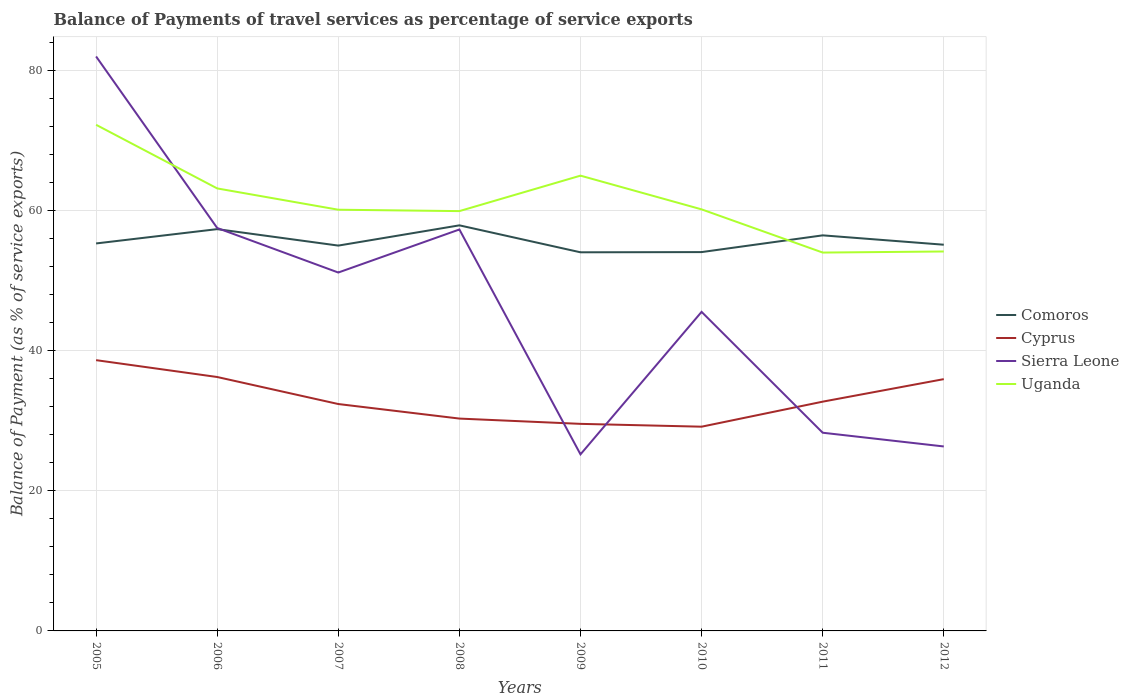How many different coloured lines are there?
Keep it short and to the point. 4. Across all years, what is the maximum balance of payments of travel services in Comoros?
Provide a short and direct response. 54.01. What is the total balance of payments of travel services in Uganda in the graph?
Offer a terse response. 2.99. What is the difference between the highest and the second highest balance of payments of travel services in Comoros?
Your answer should be very brief. 3.85. Is the balance of payments of travel services in Comoros strictly greater than the balance of payments of travel services in Sierra Leone over the years?
Give a very brief answer. No. How many years are there in the graph?
Make the answer very short. 8. How are the legend labels stacked?
Ensure brevity in your answer.  Vertical. What is the title of the graph?
Make the answer very short. Balance of Payments of travel services as percentage of service exports. Does "Senegal" appear as one of the legend labels in the graph?
Your answer should be very brief. No. What is the label or title of the Y-axis?
Provide a succinct answer. Balance of Payment (as % of service exports). What is the Balance of Payment (as % of service exports) of Comoros in 2005?
Offer a terse response. 55.27. What is the Balance of Payment (as % of service exports) of Cyprus in 2005?
Give a very brief answer. 38.62. What is the Balance of Payment (as % of service exports) in Sierra Leone in 2005?
Ensure brevity in your answer.  81.94. What is the Balance of Payment (as % of service exports) in Uganda in 2005?
Keep it short and to the point. 72.2. What is the Balance of Payment (as % of service exports) in Comoros in 2006?
Make the answer very short. 57.31. What is the Balance of Payment (as % of service exports) of Cyprus in 2006?
Keep it short and to the point. 36.22. What is the Balance of Payment (as % of service exports) of Sierra Leone in 2006?
Provide a succinct answer. 57.47. What is the Balance of Payment (as % of service exports) in Uganda in 2006?
Make the answer very short. 63.12. What is the Balance of Payment (as % of service exports) of Comoros in 2007?
Give a very brief answer. 54.96. What is the Balance of Payment (as % of service exports) in Cyprus in 2007?
Make the answer very short. 32.36. What is the Balance of Payment (as % of service exports) of Sierra Leone in 2007?
Ensure brevity in your answer.  51.12. What is the Balance of Payment (as % of service exports) in Uganda in 2007?
Your response must be concise. 60.08. What is the Balance of Payment (as % of service exports) in Comoros in 2008?
Keep it short and to the point. 57.85. What is the Balance of Payment (as % of service exports) of Cyprus in 2008?
Offer a terse response. 30.29. What is the Balance of Payment (as % of service exports) in Sierra Leone in 2008?
Your answer should be very brief. 57.26. What is the Balance of Payment (as % of service exports) of Uganda in 2008?
Your answer should be compact. 59.88. What is the Balance of Payment (as % of service exports) in Comoros in 2009?
Keep it short and to the point. 54.01. What is the Balance of Payment (as % of service exports) in Cyprus in 2009?
Make the answer very short. 29.53. What is the Balance of Payment (as % of service exports) in Sierra Leone in 2009?
Your response must be concise. 25.19. What is the Balance of Payment (as % of service exports) of Uganda in 2009?
Provide a succinct answer. 64.94. What is the Balance of Payment (as % of service exports) of Comoros in 2010?
Ensure brevity in your answer.  54.04. What is the Balance of Payment (as % of service exports) of Cyprus in 2010?
Your answer should be compact. 29.13. What is the Balance of Payment (as % of service exports) in Sierra Leone in 2010?
Offer a very short reply. 45.51. What is the Balance of Payment (as % of service exports) in Uganda in 2010?
Offer a very short reply. 60.13. What is the Balance of Payment (as % of service exports) in Comoros in 2011?
Your answer should be compact. 56.42. What is the Balance of Payment (as % of service exports) of Cyprus in 2011?
Give a very brief answer. 32.7. What is the Balance of Payment (as % of service exports) in Sierra Leone in 2011?
Ensure brevity in your answer.  28.27. What is the Balance of Payment (as % of service exports) in Uganda in 2011?
Your answer should be compact. 53.97. What is the Balance of Payment (as % of service exports) in Comoros in 2012?
Your response must be concise. 55.09. What is the Balance of Payment (as % of service exports) in Cyprus in 2012?
Your response must be concise. 35.91. What is the Balance of Payment (as % of service exports) in Sierra Leone in 2012?
Offer a terse response. 26.31. What is the Balance of Payment (as % of service exports) in Uganda in 2012?
Your answer should be compact. 54.12. Across all years, what is the maximum Balance of Payment (as % of service exports) of Comoros?
Provide a short and direct response. 57.85. Across all years, what is the maximum Balance of Payment (as % of service exports) of Cyprus?
Ensure brevity in your answer.  38.62. Across all years, what is the maximum Balance of Payment (as % of service exports) in Sierra Leone?
Ensure brevity in your answer.  81.94. Across all years, what is the maximum Balance of Payment (as % of service exports) of Uganda?
Offer a terse response. 72.2. Across all years, what is the minimum Balance of Payment (as % of service exports) of Comoros?
Make the answer very short. 54.01. Across all years, what is the minimum Balance of Payment (as % of service exports) in Cyprus?
Provide a short and direct response. 29.13. Across all years, what is the minimum Balance of Payment (as % of service exports) of Sierra Leone?
Ensure brevity in your answer.  25.19. Across all years, what is the minimum Balance of Payment (as % of service exports) in Uganda?
Provide a succinct answer. 53.97. What is the total Balance of Payment (as % of service exports) in Comoros in the graph?
Ensure brevity in your answer.  444.95. What is the total Balance of Payment (as % of service exports) of Cyprus in the graph?
Offer a very short reply. 264.78. What is the total Balance of Payment (as % of service exports) of Sierra Leone in the graph?
Offer a very short reply. 373.07. What is the total Balance of Payment (as % of service exports) in Uganda in the graph?
Offer a terse response. 488.44. What is the difference between the Balance of Payment (as % of service exports) in Comoros in 2005 and that in 2006?
Provide a succinct answer. -2.04. What is the difference between the Balance of Payment (as % of service exports) of Cyprus in 2005 and that in 2006?
Make the answer very short. 2.4. What is the difference between the Balance of Payment (as % of service exports) in Sierra Leone in 2005 and that in 2006?
Your answer should be compact. 24.47. What is the difference between the Balance of Payment (as % of service exports) in Uganda in 2005 and that in 2006?
Ensure brevity in your answer.  9.08. What is the difference between the Balance of Payment (as % of service exports) of Comoros in 2005 and that in 2007?
Give a very brief answer. 0.31. What is the difference between the Balance of Payment (as % of service exports) of Cyprus in 2005 and that in 2007?
Offer a very short reply. 6.26. What is the difference between the Balance of Payment (as % of service exports) in Sierra Leone in 2005 and that in 2007?
Ensure brevity in your answer.  30.82. What is the difference between the Balance of Payment (as % of service exports) in Uganda in 2005 and that in 2007?
Make the answer very short. 12.11. What is the difference between the Balance of Payment (as % of service exports) of Comoros in 2005 and that in 2008?
Your answer should be compact. -2.58. What is the difference between the Balance of Payment (as % of service exports) of Cyprus in 2005 and that in 2008?
Provide a short and direct response. 8.33. What is the difference between the Balance of Payment (as % of service exports) in Sierra Leone in 2005 and that in 2008?
Provide a succinct answer. 24.68. What is the difference between the Balance of Payment (as % of service exports) of Uganda in 2005 and that in 2008?
Provide a succinct answer. 12.31. What is the difference between the Balance of Payment (as % of service exports) in Comoros in 2005 and that in 2009?
Offer a very short reply. 1.26. What is the difference between the Balance of Payment (as % of service exports) in Cyprus in 2005 and that in 2009?
Your response must be concise. 9.09. What is the difference between the Balance of Payment (as % of service exports) in Sierra Leone in 2005 and that in 2009?
Your answer should be very brief. 56.75. What is the difference between the Balance of Payment (as % of service exports) in Uganda in 2005 and that in 2009?
Offer a very short reply. 7.25. What is the difference between the Balance of Payment (as % of service exports) of Comoros in 2005 and that in 2010?
Ensure brevity in your answer.  1.23. What is the difference between the Balance of Payment (as % of service exports) in Cyprus in 2005 and that in 2010?
Your answer should be compact. 9.49. What is the difference between the Balance of Payment (as % of service exports) in Sierra Leone in 2005 and that in 2010?
Give a very brief answer. 36.43. What is the difference between the Balance of Payment (as % of service exports) of Uganda in 2005 and that in 2010?
Your response must be concise. 12.06. What is the difference between the Balance of Payment (as % of service exports) of Comoros in 2005 and that in 2011?
Keep it short and to the point. -1.16. What is the difference between the Balance of Payment (as % of service exports) of Cyprus in 2005 and that in 2011?
Offer a very short reply. 5.92. What is the difference between the Balance of Payment (as % of service exports) in Sierra Leone in 2005 and that in 2011?
Provide a short and direct response. 53.67. What is the difference between the Balance of Payment (as % of service exports) of Uganda in 2005 and that in 2011?
Provide a short and direct response. 18.23. What is the difference between the Balance of Payment (as % of service exports) of Comoros in 2005 and that in 2012?
Provide a succinct answer. 0.18. What is the difference between the Balance of Payment (as % of service exports) of Cyprus in 2005 and that in 2012?
Ensure brevity in your answer.  2.71. What is the difference between the Balance of Payment (as % of service exports) of Sierra Leone in 2005 and that in 2012?
Ensure brevity in your answer.  55.63. What is the difference between the Balance of Payment (as % of service exports) in Uganda in 2005 and that in 2012?
Provide a short and direct response. 18.07. What is the difference between the Balance of Payment (as % of service exports) of Comoros in 2006 and that in 2007?
Ensure brevity in your answer.  2.35. What is the difference between the Balance of Payment (as % of service exports) of Cyprus in 2006 and that in 2007?
Provide a succinct answer. 3.85. What is the difference between the Balance of Payment (as % of service exports) in Sierra Leone in 2006 and that in 2007?
Your answer should be very brief. 6.35. What is the difference between the Balance of Payment (as % of service exports) of Uganda in 2006 and that in 2007?
Offer a very short reply. 3.04. What is the difference between the Balance of Payment (as % of service exports) of Comoros in 2006 and that in 2008?
Provide a short and direct response. -0.54. What is the difference between the Balance of Payment (as % of service exports) in Cyprus in 2006 and that in 2008?
Make the answer very short. 5.93. What is the difference between the Balance of Payment (as % of service exports) of Sierra Leone in 2006 and that in 2008?
Offer a terse response. 0.21. What is the difference between the Balance of Payment (as % of service exports) of Uganda in 2006 and that in 2008?
Provide a succinct answer. 3.24. What is the difference between the Balance of Payment (as % of service exports) of Comoros in 2006 and that in 2009?
Offer a terse response. 3.3. What is the difference between the Balance of Payment (as % of service exports) of Cyprus in 2006 and that in 2009?
Offer a terse response. 6.68. What is the difference between the Balance of Payment (as % of service exports) of Sierra Leone in 2006 and that in 2009?
Your answer should be very brief. 32.29. What is the difference between the Balance of Payment (as % of service exports) of Uganda in 2006 and that in 2009?
Keep it short and to the point. -1.82. What is the difference between the Balance of Payment (as % of service exports) in Comoros in 2006 and that in 2010?
Give a very brief answer. 3.27. What is the difference between the Balance of Payment (as % of service exports) of Cyprus in 2006 and that in 2010?
Give a very brief answer. 7.09. What is the difference between the Balance of Payment (as % of service exports) of Sierra Leone in 2006 and that in 2010?
Make the answer very short. 11.96. What is the difference between the Balance of Payment (as % of service exports) of Uganda in 2006 and that in 2010?
Give a very brief answer. 2.99. What is the difference between the Balance of Payment (as % of service exports) of Comoros in 2006 and that in 2011?
Provide a short and direct response. 0.89. What is the difference between the Balance of Payment (as % of service exports) in Cyprus in 2006 and that in 2011?
Give a very brief answer. 3.52. What is the difference between the Balance of Payment (as % of service exports) in Sierra Leone in 2006 and that in 2011?
Keep it short and to the point. 29.2. What is the difference between the Balance of Payment (as % of service exports) of Uganda in 2006 and that in 2011?
Offer a terse response. 9.15. What is the difference between the Balance of Payment (as % of service exports) in Comoros in 2006 and that in 2012?
Your answer should be compact. 2.22. What is the difference between the Balance of Payment (as % of service exports) in Cyprus in 2006 and that in 2012?
Offer a very short reply. 0.3. What is the difference between the Balance of Payment (as % of service exports) of Sierra Leone in 2006 and that in 2012?
Your answer should be very brief. 31.16. What is the difference between the Balance of Payment (as % of service exports) in Uganda in 2006 and that in 2012?
Give a very brief answer. 9. What is the difference between the Balance of Payment (as % of service exports) of Comoros in 2007 and that in 2008?
Provide a succinct answer. -2.89. What is the difference between the Balance of Payment (as % of service exports) in Cyprus in 2007 and that in 2008?
Your answer should be compact. 2.07. What is the difference between the Balance of Payment (as % of service exports) of Sierra Leone in 2007 and that in 2008?
Offer a terse response. -6.14. What is the difference between the Balance of Payment (as % of service exports) of Uganda in 2007 and that in 2008?
Give a very brief answer. 0.2. What is the difference between the Balance of Payment (as % of service exports) in Comoros in 2007 and that in 2009?
Your response must be concise. 0.96. What is the difference between the Balance of Payment (as % of service exports) of Cyprus in 2007 and that in 2009?
Offer a very short reply. 2.83. What is the difference between the Balance of Payment (as % of service exports) in Sierra Leone in 2007 and that in 2009?
Provide a short and direct response. 25.94. What is the difference between the Balance of Payment (as % of service exports) of Uganda in 2007 and that in 2009?
Ensure brevity in your answer.  -4.86. What is the difference between the Balance of Payment (as % of service exports) of Comoros in 2007 and that in 2010?
Ensure brevity in your answer.  0.93. What is the difference between the Balance of Payment (as % of service exports) in Cyprus in 2007 and that in 2010?
Offer a terse response. 3.23. What is the difference between the Balance of Payment (as % of service exports) in Sierra Leone in 2007 and that in 2010?
Give a very brief answer. 5.61. What is the difference between the Balance of Payment (as % of service exports) in Uganda in 2007 and that in 2010?
Your answer should be compact. -0.05. What is the difference between the Balance of Payment (as % of service exports) of Comoros in 2007 and that in 2011?
Keep it short and to the point. -1.46. What is the difference between the Balance of Payment (as % of service exports) of Cyprus in 2007 and that in 2011?
Ensure brevity in your answer.  -0.34. What is the difference between the Balance of Payment (as % of service exports) of Sierra Leone in 2007 and that in 2011?
Make the answer very short. 22.85. What is the difference between the Balance of Payment (as % of service exports) of Uganda in 2007 and that in 2011?
Make the answer very short. 6.11. What is the difference between the Balance of Payment (as % of service exports) in Comoros in 2007 and that in 2012?
Your answer should be compact. -0.12. What is the difference between the Balance of Payment (as % of service exports) in Cyprus in 2007 and that in 2012?
Make the answer very short. -3.55. What is the difference between the Balance of Payment (as % of service exports) of Sierra Leone in 2007 and that in 2012?
Provide a short and direct response. 24.81. What is the difference between the Balance of Payment (as % of service exports) in Uganda in 2007 and that in 2012?
Your response must be concise. 5.96. What is the difference between the Balance of Payment (as % of service exports) in Comoros in 2008 and that in 2009?
Provide a succinct answer. 3.85. What is the difference between the Balance of Payment (as % of service exports) in Cyprus in 2008 and that in 2009?
Make the answer very short. 0.75. What is the difference between the Balance of Payment (as % of service exports) of Sierra Leone in 2008 and that in 2009?
Ensure brevity in your answer.  32.08. What is the difference between the Balance of Payment (as % of service exports) of Uganda in 2008 and that in 2009?
Your response must be concise. -5.06. What is the difference between the Balance of Payment (as % of service exports) in Comoros in 2008 and that in 2010?
Offer a terse response. 3.81. What is the difference between the Balance of Payment (as % of service exports) in Cyprus in 2008 and that in 2010?
Give a very brief answer. 1.16. What is the difference between the Balance of Payment (as % of service exports) in Sierra Leone in 2008 and that in 2010?
Provide a short and direct response. 11.75. What is the difference between the Balance of Payment (as % of service exports) of Uganda in 2008 and that in 2010?
Make the answer very short. -0.25. What is the difference between the Balance of Payment (as % of service exports) of Comoros in 2008 and that in 2011?
Keep it short and to the point. 1.43. What is the difference between the Balance of Payment (as % of service exports) in Cyprus in 2008 and that in 2011?
Your answer should be compact. -2.41. What is the difference between the Balance of Payment (as % of service exports) of Sierra Leone in 2008 and that in 2011?
Your answer should be compact. 28.99. What is the difference between the Balance of Payment (as % of service exports) of Uganda in 2008 and that in 2011?
Provide a short and direct response. 5.91. What is the difference between the Balance of Payment (as % of service exports) of Comoros in 2008 and that in 2012?
Your answer should be very brief. 2.76. What is the difference between the Balance of Payment (as % of service exports) in Cyprus in 2008 and that in 2012?
Offer a terse response. -5.63. What is the difference between the Balance of Payment (as % of service exports) in Sierra Leone in 2008 and that in 2012?
Your response must be concise. 30.95. What is the difference between the Balance of Payment (as % of service exports) of Uganda in 2008 and that in 2012?
Your response must be concise. 5.76. What is the difference between the Balance of Payment (as % of service exports) of Comoros in 2009 and that in 2010?
Your answer should be very brief. -0.03. What is the difference between the Balance of Payment (as % of service exports) of Cyprus in 2009 and that in 2010?
Provide a succinct answer. 0.4. What is the difference between the Balance of Payment (as % of service exports) of Sierra Leone in 2009 and that in 2010?
Provide a short and direct response. -20.33. What is the difference between the Balance of Payment (as % of service exports) in Uganda in 2009 and that in 2010?
Offer a very short reply. 4.81. What is the difference between the Balance of Payment (as % of service exports) in Comoros in 2009 and that in 2011?
Keep it short and to the point. -2.42. What is the difference between the Balance of Payment (as % of service exports) of Cyprus in 2009 and that in 2011?
Keep it short and to the point. -3.17. What is the difference between the Balance of Payment (as % of service exports) of Sierra Leone in 2009 and that in 2011?
Make the answer very short. -3.09. What is the difference between the Balance of Payment (as % of service exports) of Uganda in 2009 and that in 2011?
Keep it short and to the point. 10.97. What is the difference between the Balance of Payment (as % of service exports) in Comoros in 2009 and that in 2012?
Give a very brief answer. -1.08. What is the difference between the Balance of Payment (as % of service exports) in Cyprus in 2009 and that in 2012?
Keep it short and to the point. -6.38. What is the difference between the Balance of Payment (as % of service exports) of Sierra Leone in 2009 and that in 2012?
Make the answer very short. -1.13. What is the difference between the Balance of Payment (as % of service exports) in Uganda in 2009 and that in 2012?
Provide a short and direct response. 10.82. What is the difference between the Balance of Payment (as % of service exports) in Comoros in 2010 and that in 2011?
Your answer should be compact. -2.39. What is the difference between the Balance of Payment (as % of service exports) of Cyprus in 2010 and that in 2011?
Give a very brief answer. -3.57. What is the difference between the Balance of Payment (as % of service exports) in Sierra Leone in 2010 and that in 2011?
Your response must be concise. 17.24. What is the difference between the Balance of Payment (as % of service exports) of Uganda in 2010 and that in 2011?
Provide a short and direct response. 6.16. What is the difference between the Balance of Payment (as % of service exports) in Comoros in 2010 and that in 2012?
Ensure brevity in your answer.  -1.05. What is the difference between the Balance of Payment (as % of service exports) of Cyprus in 2010 and that in 2012?
Offer a terse response. -6.78. What is the difference between the Balance of Payment (as % of service exports) of Sierra Leone in 2010 and that in 2012?
Keep it short and to the point. 19.2. What is the difference between the Balance of Payment (as % of service exports) in Uganda in 2010 and that in 2012?
Provide a short and direct response. 6.01. What is the difference between the Balance of Payment (as % of service exports) in Comoros in 2011 and that in 2012?
Your answer should be very brief. 1.34. What is the difference between the Balance of Payment (as % of service exports) of Cyprus in 2011 and that in 2012?
Offer a terse response. -3.21. What is the difference between the Balance of Payment (as % of service exports) in Sierra Leone in 2011 and that in 2012?
Offer a terse response. 1.96. What is the difference between the Balance of Payment (as % of service exports) of Uganda in 2011 and that in 2012?
Your answer should be very brief. -0.15. What is the difference between the Balance of Payment (as % of service exports) in Comoros in 2005 and the Balance of Payment (as % of service exports) in Cyprus in 2006?
Make the answer very short. 19.05. What is the difference between the Balance of Payment (as % of service exports) of Comoros in 2005 and the Balance of Payment (as % of service exports) of Sierra Leone in 2006?
Your answer should be very brief. -2.2. What is the difference between the Balance of Payment (as % of service exports) in Comoros in 2005 and the Balance of Payment (as % of service exports) in Uganda in 2006?
Your answer should be very brief. -7.85. What is the difference between the Balance of Payment (as % of service exports) in Cyprus in 2005 and the Balance of Payment (as % of service exports) in Sierra Leone in 2006?
Give a very brief answer. -18.85. What is the difference between the Balance of Payment (as % of service exports) in Cyprus in 2005 and the Balance of Payment (as % of service exports) in Uganda in 2006?
Make the answer very short. -24.5. What is the difference between the Balance of Payment (as % of service exports) of Sierra Leone in 2005 and the Balance of Payment (as % of service exports) of Uganda in 2006?
Offer a terse response. 18.82. What is the difference between the Balance of Payment (as % of service exports) of Comoros in 2005 and the Balance of Payment (as % of service exports) of Cyprus in 2007?
Ensure brevity in your answer.  22.91. What is the difference between the Balance of Payment (as % of service exports) in Comoros in 2005 and the Balance of Payment (as % of service exports) in Sierra Leone in 2007?
Keep it short and to the point. 4.15. What is the difference between the Balance of Payment (as % of service exports) in Comoros in 2005 and the Balance of Payment (as % of service exports) in Uganda in 2007?
Your answer should be very brief. -4.81. What is the difference between the Balance of Payment (as % of service exports) of Cyprus in 2005 and the Balance of Payment (as % of service exports) of Sierra Leone in 2007?
Make the answer very short. -12.5. What is the difference between the Balance of Payment (as % of service exports) of Cyprus in 2005 and the Balance of Payment (as % of service exports) of Uganda in 2007?
Your answer should be very brief. -21.46. What is the difference between the Balance of Payment (as % of service exports) of Sierra Leone in 2005 and the Balance of Payment (as % of service exports) of Uganda in 2007?
Ensure brevity in your answer.  21.86. What is the difference between the Balance of Payment (as % of service exports) in Comoros in 2005 and the Balance of Payment (as % of service exports) in Cyprus in 2008?
Provide a short and direct response. 24.98. What is the difference between the Balance of Payment (as % of service exports) in Comoros in 2005 and the Balance of Payment (as % of service exports) in Sierra Leone in 2008?
Offer a terse response. -1.99. What is the difference between the Balance of Payment (as % of service exports) of Comoros in 2005 and the Balance of Payment (as % of service exports) of Uganda in 2008?
Give a very brief answer. -4.61. What is the difference between the Balance of Payment (as % of service exports) in Cyprus in 2005 and the Balance of Payment (as % of service exports) in Sierra Leone in 2008?
Your answer should be compact. -18.64. What is the difference between the Balance of Payment (as % of service exports) of Cyprus in 2005 and the Balance of Payment (as % of service exports) of Uganda in 2008?
Keep it short and to the point. -21.26. What is the difference between the Balance of Payment (as % of service exports) of Sierra Leone in 2005 and the Balance of Payment (as % of service exports) of Uganda in 2008?
Your response must be concise. 22.06. What is the difference between the Balance of Payment (as % of service exports) in Comoros in 2005 and the Balance of Payment (as % of service exports) in Cyprus in 2009?
Your answer should be very brief. 25.73. What is the difference between the Balance of Payment (as % of service exports) in Comoros in 2005 and the Balance of Payment (as % of service exports) in Sierra Leone in 2009?
Make the answer very short. 30.08. What is the difference between the Balance of Payment (as % of service exports) of Comoros in 2005 and the Balance of Payment (as % of service exports) of Uganda in 2009?
Give a very brief answer. -9.67. What is the difference between the Balance of Payment (as % of service exports) of Cyprus in 2005 and the Balance of Payment (as % of service exports) of Sierra Leone in 2009?
Your response must be concise. 13.44. What is the difference between the Balance of Payment (as % of service exports) in Cyprus in 2005 and the Balance of Payment (as % of service exports) in Uganda in 2009?
Provide a succinct answer. -26.32. What is the difference between the Balance of Payment (as % of service exports) of Sierra Leone in 2005 and the Balance of Payment (as % of service exports) of Uganda in 2009?
Provide a succinct answer. 17. What is the difference between the Balance of Payment (as % of service exports) of Comoros in 2005 and the Balance of Payment (as % of service exports) of Cyprus in 2010?
Keep it short and to the point. 26.14. What is the difference between the Balance of Payment (as % of service exports) of Comoros in 2005 and the Balance of Payment (as % of service exports) of Sierra Leone in 2010?
Ensure brevity in your answer.  9.76. What is the difference between the Balance of Payment (as % of service exports) of Comoros in 2005 and the Balance of Payment (as % of service exports) of Uganda in 2010?
Offer a very short reply. -4.86. What is the difference between the Balance of Payment (as % of service exports) in Cyprus in 2005 and the Balance of Payment (as % of service exports) in Sierra Leone in 2010?
Your response must be concise. -6.89. What is the difference between the Balance of Payment (as % of service exports) in Cyprus in 2005 and the Balance of Payment (as % of service exports) in Uganda in 2010?
Your response must be concise. -21.51. What is the difference between the Balance of Payment (as % of service exports) in Sierra Leone in 2005 and the Balance of Payment (as % of service exports) in Uganda in 2010?
Your answer should be compact. 21.81. What is the difference between the Balance of Payment (as % of service exports) in Comoros in 2005 and the Balance of Payment (as % of service exports) in Cyprus in 2011?
Offer a very short reply. 22.57. What is the difference between the Balance of Payment (as % of service exports) in Comoros in 2005 and the Balance of Payment (as % of service exports) in Sierra Leone in 2011?
Provide a short and direct response. 27. What is the difference between the Balance of Payment (as % of service exports) of Comoros in 2005 and the Balance of Payment (as % of service exports) of Uganda in 2011?
Ensure brevity in your answer.  1.3. What is the difference between the Balance of Payment (as % of service exports) of Cyprus in 2005 and the Balance of Payment (as % of service exports) of Sierra Leone in 2011?
Ensure brevity in your answer.  10.35. What is the difference between the Balance of Payment (as % of service exports) of Cyprus in 2005 and the Balance of Payment (as % of service exports) of Uganda in 2011?
Ensure brevity in your answer.  -15.35. What is the difference between the Balance of Payment (as % of service exports) of Sierra Leone in 2005 and the Balance of Payment (as % of service exports) of Uganda in 2011?
Offer a terse response. 27.97. What is the difference between the Balance of Payment (as % of service exports) in Comoros in 2005 and the Balance of Payment (as % of service exports) in Cyprus in 2012?
Ensure brevity in your answer.  19.35. What is the difference between the Balance of Payment (as % of service exports) in Comoros in 2005 and the Balance of Payment (as % of service exports) in Sierra Leone in 2012?
Your answer should be compact. 28.96. What is the difference between the Balance of Payment (as % of service exports) in Comoros in 2005 and the Balance of Payment (as % of service exports) in Uganda in 2012?
Give a very brief answer. 1.15. What is the difference between the Balance of Payment (as % of service exports) of Cyprus in 2005 and the Balance of Payment (as % of service exports) of Sierra Leone in 2012?
Your answer should be very brief. 12.31. What is the difference between the Balance of Payment (as % of service exports) in Cyprus in 2005 and the Balance of Payment (as % of service exports) in Uganda in 2012?
Offer a very short reply. -15.5. What is the difference between the Balance of Payment (as % of service exports) in Sierra Leone in 2005 and the Balance of Payment (as % of service exports) in Uganda in 2012?
Your response must be concise. 27.82. What is the difference between the Balance of Payment (as % of service exports) of Comoros in 2006 and the Balance of Payment (as % of service exports) of Cyprus in 2007?
Make the answer very short. 24.95. What is the difference between the Balance of Payment (as % of service exports) of Comoros in 2006 and the Balance of Payment (as % of service exports) of Sierra Leone in 2007?
Your answer should be compact. 6.19. What is the difference between the Balance of Payment (as % of service exports) in Comoros in 2006 and the Balance of Payment (as % of service exports) in Uganda in 2007?
Provide a short and direct response. -2.77. What is the difference between the Balance of Payment (as % of service exports) in Cyprus in 2006 and the Balance of Payment (as % of service exports) in Sierra Leone in 2007?
Offer a very short reply. -14.9. What is the difference between the Balance of Payment (as % of service exports) in Cyprus in 2006 and the Balance of Payment (as % of service exports) in Uganda in 2007?
Provide a short and direct response. -23.86. What is the difference between the Balance of Payment (as % of service exports) of Sierra Leone in 2006 and the Balance of Payment (as % of service exports) of Uganda in 2007?
Your answer should be compact. -2.61. What is the difference between the Balance of Payment (as % of service exports) in Comoros in 2006 and the Balance of Payment (as % of service exports) in Cyprus in 2008?
Give a very brief answer. 27.02. What is the difference between the Balance of Payment (as % of service exports) of Comoros in 2006 and the Balance of Payment (as % of service exports) of Sierra Leone in 2008?
Your response must be concise. 0.05. What is the difference between the Balance of Payment (as % of service exports) in Comoros in 2006 and the Balance of Payment (as % of service exports) in Uganda in 2008?
Provide a succinct answer. -2.57. What is the difference between the Balance of Payment (as % of service exports) of Cyprus in 2006 and the Balance of Payment (as % of service exports) of Sierra Leone in 2008?
Provide a succinct answer. -21.04. What is the difference between the Balance of Payment (as % of service exports) in Cyprus in 2006 and the Balance of Payment (as % of service exports) in Uganda in 2008?
Make the answer very short. -23.66. What is the difference between the Balance of Payment (as % of service exports) in Sierra Leone in 2006 and the Balance of Payment (as % of service exports) in Uganda in 2008?
Your response must be concise. -2.41. What is the difference between the Balance of Payment (as % of service exports) in Comoros in 2006 and the Balance of Payment (as % of service exports) in Cyprus in 2009?
Give a very brief answer. 27.78. What is the difference between the Balance of Payment (as % of service exports) in Comoros in 2006 and the Balance of Payment (as % of service exports) in Sierra Leone in 2009?
Give a very brief answer. 32.12. What is the difference between the Balance of Payment (as % of service exports) of Comoros in 2006 and the Balance of Payment (as % of service exports) of Uganda in 2009?
Provide a short and direct response. -7.63. What is the difference between the Balance of Payment (as % of service exports) of Cyprus in 2006 and the Balance of Payment (as % of service exports) of Sierra Leone in 2009?
Your answer should be compact. 11.03. What is the difference between the Balance of Payment (as % of service exports) in Cyprus in 2006 and the Balance of Payment (as % of service exports) in Uganda in 2009?
Ensure brevity in your answer.  -28.72. What is the difference between the Balance of Payment (as % of service exports) of Sierra Leone in 2006 and the Balance of Payment (as % of service exports) of Uganda in 2009?
Your answer should be compact. -7.47. What is the difference between the Balance of Payment (as % of service exports) of Comoros in 2006 and the Balance of Payment (as % of service exports) of Cyprus in 2010?
Provide a succinct answer. 28.18. What is the difference between the Balance of Payment (as % of service exports) in Comoros in 2006 and the Balance of Payment (as % of service exports) in Sierra Leone in 2010?
Keep it short and to the point. 11.8. What is the difference between the Balance of Payment (as % of service exports) of Comoros in 2006 and the Balance of Payment (as % of service exports) of Uganda in 2010?
Give a very brief answer. -2.82. What is the difference between the Balance of Payment (as % of service exports) in Cyprus in 2006 and the Balance of Payment (as % of service exports) in Sierra Leone in 2010?
Offer a terse response. -9.29. What is the difference between the Balance of Payment (as % of service exports) of Cyprus in 2006 and the Balance of Payment (as % of service exports) of Uganda in 2010?
Provide a short and direct response. -23.91. What is the difference between the Balance of Payment (as % of service exports) of Sierra Leone in 2006 and the Balance of Payment (as % of service exports) of Uganda in 2010?
Make the answer very short. -2.66. What is the difference between the Balance of Payment (as % of service exports) in Comoros in 2006 and the Balance of Payment (as % of service exports) in Cyprus in 2011?
Make the answer very short. 24.61. What is the difference between the Balance of Payment (as % of service exports) of Comoros in 2006 and the Balance of Payment (as % of service exports) of Sierra Leone in 2011?
Keep it short and to the point. 29.04. What is the difference between the Balance of Payment (as % of service exports) in Comoros in 2006 and the Balance of Payment (as % of service exports) in Uganda in 2011?
Your answer should be very brief. 3.34. What is the difference between the Balance of Payment (as % of service exports) in Cyprus in 2006 and the Balance of Payment (as % of service exports) in Sierra Leone in 2011?
Keep it short and to the point. 7.95. What is the difference between the Balance of Payment (as % of service exports) in Cyprus in 2006 and the Balance of Payment (as % of service exports) in Uganda in 2011?
Keep it short and to the point. -17.75. What is the difference between the Balance of Payment (as % of service exports) in Sierra Leone in 2006 and the Balance of Payment (as % of service exports) in Uganda in 2011?
Give a very brief answer. 3.5. What is the difference between the Balance of Payment (as % of service exports) in Comoros in 2006 and the Balance of Payment (as % of service exports) in Cyprus in 2012?
Your answer should be compact. 21.4. What is the difference between the Balance of Payment (as % of service exports) in Comoros in 2006 and the Balance of Payment (as % of service exports) in Sierra Leone in 2012?
Provide a succinct answer. 31. What is the difference between the Balance of Payment (as % of service exports) in Comoros in 2006 and the Balance of Payment (as % of service exports) in Uganda in 2012?
Ensure brevity in your answer.  3.19. What is the difference between the Balance of Payment (as % of service exports) in Cyprus in 2006 and the Balance of Payment (as % of service exports) in Sierra Leone in 2012?
Offer a very short reply. 9.91. What is the difference between the Balance of Payment (as % of service exports) in Cyprus in 2006 and the Balance of Payment (as % of service exports) in Uganda in 2012?
Offer a very short reply. -17.9. What is the difference between the Balance of Payment (as % of service exports) in Sierra Leone in 2006 and the Balance of Payment (as % of service exports) in Uganda in 2012?
Ensure brevity in your answer.  3.35. What is the difference between the Balance of Payment (as % of service exports) in Comoros in 2007 and the Balance of Payment (as % of service exports) in Cyprus in 2008?
Your answer should be very brief. 24.67. What is the difference between the Balance of Payment (as % of service exports) of Comoros in 2007 and the Balance of Payment (as % of service exports) of Sierra Leone in 2008?
Give a very brief answer. -2.3. What is the difference between the Balance of Payment (as % of service exports) in Comoros in 2007 and the Balance of Payment (as % of service exports) in Uganda in 2008?
Your answer should be very brief. -4.92. What is the difference between the Balance of Payment (as % of service exports) of Cyprus in 2007 and the Balance of Payment (as % of service exports) of Sierra Leone in 2008?
Provide a short and direct response. -24.9. What is the difference between the Balance of Payment (as % of service exports) of Cyprus in 2007 and the Balance of Payment (as % of service exports) of Uganda in 2008?
Give a very brief answer. -27.52. What is the difference between the Balance of Payment (as % of service exports) in Sierra Leone in 2007 and the Balance of Payment (as % of service exports) in Uganda in 2008?
Keep it short and to the point. -8.76. What is the difference between the Balance of Payment (as % of service exports) of Comoros in 2007 and the Balance of Payment (as % of service exports) of Cyprus in 2009?
Keep it short and to the point. 25.43. What is the difference between the Balance of Payment (as % of service exports) of Comoros in 2007 and the Balance of Payment (as % of service exports) of Sierra Leone in 2009?
Give a very brief answer. 29.78. What is the difference between the Balance of Payment (as % of service exports) of Comoros in 2007 and the Balance of Payment (as % of service exports) of Uganda in 2009?
Offer a very short reply. -9.98. What is the difference between the Balance of Payment (as % of service exports) of Cyprus in 2007 and the Balance of Payment (as % of service exports) of Sierra Leone in 2009?
Give a very brief answer. 7.18. What is the difference between the Balance of Payment (as % of service exports) of Cyprus in 2007 and the Balance of Payment (as % of service exports) of Uganda in 2009?
Offer a terse response. -32.58. What is the difference between the Balance of Payment (as % of service exports) of Sierra Leone in 2007 and the Balance of Payment (as % of service exports) of Uganda in 2009?
Offer a terse response. -13.82. What is the difference between the Balance of Payment (as % of service exports) of Comoros in 2007 and the Balance of Payment (as % of service exports) of Cyprus in 2010?
Your response must be concise. 25.83. What is the difference between the Balance of Payment (as % of service exports) in Comoros in 2007 and the Balance of Payment (as % of service exports) in Sierra Leone in 2010?
Your answer should be very brief. 9.45. What is the difference between the Balance of Payment (as % of service exports) of Comoros in 2007 and the Balance of Payment (as % of service exports) of Uganda in 2010?
Your response must be concise. -5.17. What is the difference between the Balance of Payment (as % of service exports) of Cyprus in 2007 and the Balance of Payment (as % of service exports) of Sierra Leone in 2010?
Provide a succinct answer. -13.15. What is the difference between the Balance of Payment (as % of service exports) of Cyprus in 2007 and the Balance of Payment (as % of service exports) of Uganda in 2010?
Ensure brevity in your answer.  -27.77. What is the difference between the Balance of Payment (as % of service exports) of Sierra Leone in 2007 and the Balance of Payment (as % of service exports) of Uganda in 2010?
Provide a succinct answer. -9.01. What is the difference between the Balance of Payment (as % of service exports) of Comoros in 2007 and the Balance of Payment (as % of service exports) of Cyprus in 2011?
Provide a short and direct response. 22.26. What is the difference between the Balance of Payment (as % of service exports) in Comoros in 2007 and the Balance of Payment (as % of service exports) in Sierra Leone in 2011?
Offer a very short reply. 26.69. What is the difference between the Balance of Payment (as % of service exports) in Comoros in 2007 and the Balance of Payment (as % of service exports) in Uganda in 2011?
Your response must be concise. 0.99. What is the difference between the Balance of Payment (as % of service exports) in Cyprus in 2007 and the Balance of Payment (as % of service exports) in Sierra Leone in 2011?
Provide a short and direct response. 4.09. What is the difference between the Balance of Payment (as % of service exports) in Cyprus in 2007 and the Balance of Payment (as % of service exports) in Uganda in 2011?
Ensure brevity in your answer.  -21.61. What is the difference between the Balance of Payment (as % of service exports) of Sierra Leone in 2007 and the Balance of Payment (as % of service exports) of Uganda in 2011?
Provide a short and direct response. -2.85. What is the difference between the Balance of Payment (as % of service exports) of Comoros in 2007 and the Balance of Payment (as % of service exports) of Cyprus in 2012?
Make the answer very short. 19.05. What is the difference between the Balance of Payment (as % of service exports) of Comoros in 2007 and the Balance of Payment (as % of service exports) of Sierra Leone in 2012?
Give a very brief answer. 28.65. What is the difference between the Balance of Payment (as % of service exports) in Comoros in 2007 and the Balance of Payment (as % of service exports) in Uganda in 2012?
Make the answer very short. 0.84. What is the difference between the Balance of Payment (as % of service exports) in Cyprus in 2007 and the Balance of Payment (as % of service exports) in Sierra Leone in 2012?
Provide a succinct answer. 6.05. What is the difference between the Balance of Payment (as % of service exports) of Cyprus in 2007 and the Balance of Payment (as % of service exports) of Uganda in 2012?
Offer a very short reply. -21.76. What is the difference between the Balance of Payment (as % of service exports) of Sierra Leone in 2007 and the Balance of Payment (as % of service exports) of Uganda in 2012?
Offer a very short reply. -3. What is the difference between the Balance of Payment (as % of service exports) in Comoros in 2008 and the Balance of Payment (as % of service exports) in Cyprus in 2009?
Offer a very short reply. 28.32. What is the difference between the Balance of Payment (as % of service exports) in Comoros in 2008 and the Balance of Payment (as % of service exports) in Sierra Leone in 2009?
Your answer should be very brief. 32.67. What is the difference between the Balance of Payment (as % of service exports) in Comoros in 2008 and the Balance of Payment (as % of service exports) in Uganda in 2009?
Offer a terse response. -7.09. What is the difference between the Balance of Payment (as % of service exports) of Cyprus in 2008 and the Balance of Payment (as % of service exports) of Sierra Leone in 2009?
Your response must be concise. 5.1. What is the difference between the Balance of Payment (as % of service exports) in Cyprus in 2008 and the Balance of Payment (as % of service exports) in Uganda in 2009?
Provide a short and direct response. -34.65. What is the difference between the Balance of Payment (as % of service exports) of Sierra Leone in 2008 and the Balance of Payment (as % of service exports) of Uganda in 2009?
Make the answer very short. -7.68. What is the difference between the Balance of Payment (as % of service exports) in Comoros in 2008 and the Balance of Payment (as % of service exports) in Cyprus in 2010?
Give a very brief answer. 28.72. What is the difference between the Balance of Payment (as % of service exports) of Comoros in 2008 and the Balance of Payment (as % of service exports) of Sierra Leone in 2010?
Give a very brief answer. 12.34. What is the difference between the Balance of Payment (as % of service exports) of Comoros in 2008 and the Balance of Payment (as % of service exports) of Uganda in 2010?
Ensure brevity in your answer.  -2.28. What is the difference between the Balance of Payment (as % of service exports) of Cyprus in 2008 and the Balance of Payment (as % of service exports) of Sierra Leone in 2010?
Your answer should be very brief. -15.22. What is the difference between the Balance of Payment (as % of service exports) in Cyprus in 2008 and the Balance of Payment (as % of service exports) in Uganda in 2010?
Provide a succinct answer. -29.84. What is the difference between the Balance of Payment (as % of service exports) in Sierra Leone in 2008 and the Balance of Payment (as % of service exports) in Uganda in 2010?
Provide a succinct answer. -2.87. What is the difference between the Balance of Payment (as % of service exports) in Comoros in 2008 and the Balance of Payment (as % of service exports) in Cyprus in 2011?
Offer a very short reply. 25.15. What is the difference between the Balance of Payment (as % of service exports) in Comoros in 2008 and the Balance of Payment (as % of service exports) in Sierra Leone in 2011?
Offer a terse response. 29.58. What is the difference between the Balance of Payment (as % of service exports) of Comoros in 2008 and the Balance of Payment (as % of service exports) of Uganda in 2011?
Your answer should be very brief. 3.88. What is the difference between the Balance of Payment (as % of service exports) of Cyprus in 2008 and the Balance of Payment (as % of service exports) of Sierra Leone in 2011?
Provide a succinct answer. 2.02. What is the difference between the Balance of Payment (as % of service exports) in Cyprus in 2008 and the Balance of Payment (as % of service exports) in Uganda in 2011?
Give a very brief answer. -23.68. What is the difference between the Balance of Payment (as % of service exports) in Sierra Leone in 2008 and the Balance of Payment (as % of service exports) in Uganda in 2011?
Ensure brevity in your answer.  3.29. What is the difference between the Balance of Payment (as % of service exports) of Comoros in 2008 and the Balance of Payment (as % of service exports) of Cyprus in 2012?
Make the answer very short. 21.94. What is the difference between the Balance of Payment (as % of service exports) in Comoros in 2008 and the Balance of Payment (as % of service exports) in Sierra Leone in 2012?
Offer a very short reply. 31.54. What is the difference between the Balance of Payment (as % of service exports) in Comoros in 2008 and the Balance of Payment (as % of service exports) in Uganda in 2012?
Ensure brevity in your answer.  3.73. What is the difference between the Balance of Payment (as % of service exports) in Cyprus in 2008 and the Balance of Payment (as % of service exports) in Sierra Leone in 2012?
Your response must be concise. 3.98. What is the difference between the Balance of Payment (as % of service exports) of Cyprus in 2008 and the Balance of Payment (as % of service exports) of Uganda in 2012?
Your answer should be compact. -23.83. What is the difference between the Balance of Payment (as % of service exports) of Sierra Leone in 2008 and the Balance of Payment (as % of service exports) of Uganda in 2012?
Keep it short and to the point. 3.14. What is the difference between the Balance of Payment (as % of service exports) in Comoros in 2009 and the Balance of Payment (as % of service exports) in Cyprus in 2010?
Ensure brevity in your answer.  24.87. What is the difference between the Balance of Payment (as % of service exports) in Comoros in 2009 and the Balance of Payment (as % of service exports) in Sierra Leone in 2010?
Give a very brief answer. 8.5. What is the difference between the Balance of Payment (as % of service exports) of Comoros in 2009 and the Balance of Payment (as % of service exports) of Uganda in 2010?
Your answer should be very brief. -6.12. What is the difference between the Balance of Payment (as % of service exports) in Cyprus in 2009 and the Balance of Payment (as % of service exports) in Sierra Leone in 2010?
Make the answer very short. -15.98. What is the difference between the Balance of Payment (as % of service exports) of Cyprus in 2009 and the Balance of Payment (as % of service exports) of Uganda in 2010?
Your answer should be very brief. -30.6. What is the difference between the Balance of Payment (as % of service exports) of Sierra Leone in 2009 and the Balance of Payment (as % of service exports) of Uganda in 2010?
Your answer should be very brief. -34.95. What is the difference between the Balance of Payment (as % of service exports) of Comoros in 2009 and the Balance of Payment (as % of service exports) of Cyprus in 2011?
Make the answer very short. 21.31. What is the difference between the Balance of Payment (as % of service exports) of Comoros in 2009 and the Balance of Payment (as % of service exports) of Sierra Leone in 2011?
Your answer should be very brief. 25.74. What is the difference between the Balance of Payment (as % of service exports) in Comoros in 2009 and the Balance of Payment (as % of service exports) in Uganda in 2011?
Your response must be concise. 0.04. What is the difference between the Balance of Payment (as % of service exports) of Cyprus in 2009 and the Balance of Payment (as % of service exports) of Sierra Leone in 2011?
Provide a short and direct response. 1.26. What is the difference between the Balance of Payment (as % of service exports) in Cyprus in 2009 and the Balance of Payment (as % of service exports) in Uganda in 2011?
Offer a very short reply. -24.44. What is the difference between the Balance of Payment (as % of service exports) of Sierra Leone in 2009 and the Balance of Payment (as % of service exports) of Uganda in 2011?
Keep it short and to the point. -28.78. What is the difference between the Balance of Payment (as % of service exports) in Comoros in 2009 and the Balance of Payment (as % of service exports) in Cyprus in 2012?
Provide a succinct answer. 18.09. What is the difference between the Balance of Payment (as % of service exports) of Comoros in 2009 and the Balance of Payment (as % of service exports) of Sierra Leone in 2012?
Offer a terse response. 27.7. What is the difference between the Balance of Payment (as % of service exports) of Comoros in 2009 and the Balance of Payment (as % of service exports) of Uganda in 2012?
Provide a short and direct response. -0.12. What is the difference between the Balance of Payment (as % of service exports) in Cyprus in 2009 and the Balance of Payment (as % of service exports) in Sierra Leone in 2012?
Give a very brief answer. 3.22. What is the difference between the Balance of Payment (as % of service exports) in Cyprus in 2009 and the Balance of Payment (as % of service exports) in Uganda in 2012?
Your answer should be compact. -24.59. What is the difference between the Balance of Payment (as % of service exports) in Sierra Leone in 2009 and the Balance of Payment (as % of service exports) in Uganda in 2012?
Make the answer very short. -28.94. What is the difference between the Balance of Payment (as % of service exports) of Comoros in 2010 and the Balance of Payment (as % of service exports) of Cyprus in 2011?
Provide a short and direct response. 21.34. What is the difference between the Balance of Payment (as % of service exports) in Comoros in 2010 and the Balance of Payment (as % of service exports) in Sierra Leone in 2011?
Keep it short and to the point. 25.77. What is the difference between the Balance of Payment (as % of service exports) of Comoros in 2010 and the Balance of Payment (as % of service exports) of Uganda in 2011?
Provide a short and direct response. 0.07. What is the difference between the Balance of Payment (as % of service exports) in Cyprus in 2010 and the Balance of Payment (as % of service exports) in Sierra Leone in 2011?
Provide a succinct answer. 0.86. What is the difference between the Balance of Payment (as % of service exports) of Cyprus in 2010 and the Balance of Payment (as % of service exports) of Uganda in 2011?
Keep it short and to the point. -24.84. What is the difference between the Balance of Payment (as % of service exports) in Sierra Leone in 2010 and the Balance of Payment (as % of service exports) in Uganda in 2011?
Make the answer very short. -8.46. What is the difference between the Balance of Payment (as % of service exports) in Comoros in 2010 and the Balance of Payment (as % of service exports) in Cyprus in 2012?
Offer a terse response. 18.12. What is the difference between the Balance of Payment (as % of service exports) in Comoros in 2010 and the Balance of Payment (as % of service exports) in Sierra Leone in 2012?
Ensure brevity in your answer.  27.73. What is the difference between the Balance of Payment (as % of service exports) in Comoros in 2010 and the Balance of Payment (as % of service exports) in Uganda in 2012?
Your response must be concise. -0.09. What is the difference between the Balance of Payment (as % of service exports) of Cyprus in 2010 and the Balance of Payment (as % of service exports) of Sierra Leone in 2012?
Your answer should be compact. 2.82. What is the difference between the Balance of Payment (as % of service exports) of Cyprus in 2010 and the Balance of Payment (as % of service exports) of Uganda in 2012?
Offer a terse response. -24.99. What is the difference between the Balance of Payment (as % of service exports) in Sierra Leone in 2010 and the Balance of Payment (as % of service exports) in Uganda in 2012?
Your response must be concise. -8.61. What is the difference between the Balance of Payment (as % of service exports) in Comoros in 2011 and the Balance of Payment (as % of service exports) in Cyprus in 2012?
Provide a short and direct response. 20.51. What is the difference between the Balance of Payment (as % of service exports) in Comoros in 2011 and the Balance of Payment (as % of service exports) in Sierra Leone in 2012?
Offer a terse response. 30.11. What is the difference between the Balance of Payment (as % of service exports) in Comoros in 2011 and the Balance of Payment (as % of service exports) in Uganda in 2012?
Keep it short and to the point. 2.3. What is the difference between the Balance of Payment (as % of service exports) in Cyprus in 2011 and the Balance of Payment (as % of service exports) in Sierra Leone in 2012?
Offer a very short reply. 6.39. What is the difference between the Balance of Payment (as % of service exports) in Cyprus in 2011 and the Balance of Payment (as % of service exports) in Uganda in 2012?
Your answer should be compact. -21.42. What is the difference between the Balance of Payment (as % of service exports) in Sierra Leone in 2011 and the Balance of Payment (as % of service exports) in Uganda in 2012?
Your answer should be very brief. -25.85. What is the average Balance of Payment (as % of service exports) in Comoros per year?
Provide a short and direct response. 55.62. What is the average Balance of Payment (as % of service exports) of Cyprus per year?
Your response must be concise. 33.1. What is the average Balance of Payment (as % of service exports) in Sierra Leone per year?
Offer a terse response. 46.63. What is the average Balance of Payment (as % of service exports) in Uganda per year?
Your answer should be very brief. 61.06. In the year 2005, what is the difference between the Balance of Payment (as % of service exports) in Comoros and Balance of Payment (as % of service exports) in Cyprus?
Offer a very short reply. 16.65. In the year 2005, what is the difference between the Balance of Payment (as % of service exports) in Comoros and Balance of Payment (as % of service exports) in Sierra Leone?
Make the answer very short. -26.67. In the year 2005, what is the difference between the Balance of Payment (as % of service exports) in Comoros and Balance of Payment (as % of service exports) in Uganda?
Offer a terse response. -16.93. In the year 2005, what is the difference between the Balance of Payment (as % of service exports) of Cyprus and Balance of Payment (as % of service exports) of Sierra Leone?
Provide a succinct answer. -43.32. In the year 2005, what is the difference between the Balance of Payment (as % of service exports) of Cyprus and Balance of Payment (as % of service exports) of Uganda?
Offer a very short reply. -33.57. In the year 2005, what is the difference between the Balance of Payment (as % of service exports) of Sierra Leone and Balance of Payment (as % of service exports) of Uganda?
Make the answer very short. 9.74. In the year 2006, what is the difference between the Balance of Payment (as % of service exports) of Comoros and Balance of Payment (as % of service exports) of Cyprus?
Ensure brevity in your answer.  21.09. In the year 2006, what is the difference between the Balance of Payment (as % of service exports) of Comoros and Balance of Payment (as % of service exports) of Sierra Leone?
Offer a very short reply. -0.16. In the year 2006, what is the difference between the Balance of Payment (as % of service exports) in Comoros and Balance of Payment (as % of service exports) in Uganda?
Offer a terse response. -5.81. In the year 2006, what is the difference between the Balance of Payment (as % of service exports) in Cyprus and Balance of Payment (as % of service exports) in Sierra Leone?
Your answer should be very brief. -21.25. In the year 2006, what is the difference between the Balance of Payment (as % of service exports) in Cyprus and Balance of Payment (as % of service exports) in Uganda?
Give a very brief answer. -26.9. In the year 2006, what is the difference between the Balance of Payment (as % of service exports) of Sierra Leone and Balance of Payment (as % of service exports) of Uganda?
Keep it short and to the point. -5.65. In the year 2007, what is the difference between the Balance of Payment (as % of service exports) in Comoros and Balance of Payment (as % of service exports) in Cyprus?
Ensure brevity in your answer.  22.6. In the year 2007, what is the difference between the Balance of Payment (as % of service exports) in Comoros and Balance of Payment (as % of service exports) in Sierra Leone?
Your answer should be very brief. 3.84. In the year 2007, what is the difference between the Balance of Payment (as % of service exports) of Comoros and Balance of Payment (as % of service exports) of Uganda?
Ensure brevity in your answer.  -5.12. In the year 2007, what is the difference between the Balance of Payment (as % of service exports) in Cyprus and Balance of Payment (as % of service exports) in Sierra Leone?
Give a very brief answer. -18.76. In the year 2007, what is the difference between the Balance of Payment (as % of service exports) in Cyprus and Balance of Payment (as % of service exports) in Uganda?
Ensure brevity in your answer.  -27.72. In the year 2007, what is the difference between the Balance of Payment (as % of service exports) in Sierra Leone and Balance of Payment (as % of service exports) in Uganda?
Ensure brevity in your answer.  -8.96. In the year 2008, what is the difference between the Balance of Payment (as % of service exports) in Comoros and Balance of Payment (as % of service exports) in Cyprus?
Make the answer very short. 27.56. In the year 2008, what is the difference between the Balance of Payment (as % of service exports) of Comoros and Balance of Payment (as % of service exports) of Sierra Leone?
Offer a terse response. 0.59. In the year 2008, what is the difference between the Balance of Payment (as % of service exports) in Comoros and Balance of Payment (as % of service exports) in Uganda?
Your answer should be compact. -2.03. In the year 2008, what is the difference between the Balance of Payment (as % of service exports) in Cyprus and Balance of Payment (as % of service exports) in Sierra Leone?
Make the answer very short. -26.97. In the year 2008, what is the difference between the Balance of Payment (as % of service exports) of Cyprus and Balance of Payment (as % of service exports) of Uganda?
Provide a succinct answer. -29.59. In the year 2008, what is the difference between the Balance of Payment (as % of service exports) in Sierra Leone and Balance of Payment (as % of service exports) in Uganda?
Your answer should be very brief. -2.62. In the year 2009, what is the difference between the Balance of Payment (as % of service exports) in Comoros and Balance of Payment (as % of service exports) in Cyprus?
Your response must be concise. 24.47. In the year 2009, what is the difference between the Balance of Payment (as % of service exports) of Comoros and Balance of Payment (as % of service exports) of Sierra Leone?
Offer a very short reply. 28.82. In the year 2009, what is the difference between the Balance of Payment (as % of service exports) in Comoros and Balance of Payment (as % of service exports) in Uganda?
Give a very brief answer. -10.93. In the year 2009, what is the difference between the Balance of Payment (as % of service exports) of Cyprus and Balance of Payment (as % of service exports) of Sierra Leone?
Provide a short and direct response. 4.35. In the year 2009, what is the difference between the Balance of Payment (as % of service exports) in Cyprus and Balance of Payment (as % of service exports) in Uganda?
Your answer should be very brief. -35.41. In the year 2009, what is the difference between the Balance of Payment (as % of service exports) of Sierra Leone and Balance of Payment (as % of service exports) of Uganda?
Provide a succinct answer. -39.75. In the year 2010, what is the difference between the Balance of Payment (as % of service exports) in Comoros and Balance of Payment (as % of service exports) in Cyprus?
Make the answer very short. 24.9. In the year 2010, what is the difference between the Balance of Payment (as % of service exports) in Comoros and Balance of Payment (as % of service exports) in Sierra Leone?
Ensure brevity in your answer.  8.53. In the year 2010, what is the difference between the Balance of Payment (as % of service exports) in Comoros and Balance of Payment (as % of service exports) in Uganda?
Provide a short and direct response. -6.09. In the year 2010, what is the difference between the Balance of Payment (as % of service exports) of Cyprus and Balance of Payment (as % of service exports) of Sierra Leone?
Keep it short and to the point. -16.38. In the year 2010, what is the difference between the Balance of Payment (as % of service exports) of Cyprus and Balance of Payment (as % of service exports) of Uganda?
Your response must be concise. -31. In the year 2010, what is the difference between the Balance of Payment (as % of service exports) in Sierra Leone and Balance of Payment (as % of service exports) in Uganda?
Give a very brief answer. -14.62. In the year 2011, what is the difference between the Balance of Payment (as % of service exports) of Comoros and Balance of Payment (as % of service exports) of Cyprus?
Give a very brief answer. 23.72. In the year 2011, what is the difference between the Balance of Payment (as % of service exports) in Comoros and Balance of Payment (as % of service exports) in Sierra Leone?
Offer a very short reply. 28.15. In the year 2011, what is the difference between the Balance of Payment (as % of service exports) of Comoros and Balance of Payment (as % of service exports) of Uganda?
Keep it short and to the point. 2.45. In the year 2011, what is the difference between the Balance of Payment (as % of service exports) in Cyprus and Balance of Payment (as % of service exports) in Sierra Leone?
Make the answer very short. 4.43. In the year 2011, what is the difference between the Balance of Payment (as % of service exports) in Cyprus and Balance of Payment (as % of service exports) in Uganda?
Make the answer very short. -21.27. In the year 2011, what is the difference between the Balance of Payment (as % of service exports) in Sierra Leone and Balance of Payment (as % of service exports) in Uganda?
Ensure brevity in your answer.  -25.7. In the year 2012, what is the difference between the Balance of Payment (as % of service exports) in Comoros and Balance of Payment (as % of service exports) in Cyprus?
Keep it short and to the point. 19.17. In the year 2012, what is the difference between the Balance of Payment (as % of service exports) of Comoros and Balance of Payment (as % of service exports) of Sierra Leone?
Keep it short and to the point. 28.78. In the year 2012, what is the difference between the Balance of Payment (as % of service exports) of Comoros and Balance of Payment (as % of service exports) of Uganda?
Ensure brevity in your answer.  0.97. In the year 2012, what is the difference between the Balance of Payment (as % of service exports) in Cyprus and Balance of Payment (as % of service exports) in Sierra Leone?
Offer a very short reply. 9.6. In the year 2012, what is the difference between the Balance of Payment (as % of service exports) of Cyprus and Balance of Payment (as % of service exports) of Uganda?
Offer a very short reply. -18.21. In the year 2012, what is the difference between the Balance of Payment (as % of service exports) of Sierra Leone and Balance of Payment (as % of service exports) of Uganda?
Offer a very short reply. -27.81. What is the ratio of the Balance of Payment (as % of service exports) of Comoros in 2005 to that in 2006?
Offer a very short reply. 0.96. What is the ratio of the Balance of Payment (as % of service exports) of Cyprus in 2005 to that in 2006?
Give a very brief answer. 1.07. What is the ratio of the Balance of Payment (as % of service exports) in Sierra Leone in 2005 to that in 2006?
Keep it short and to the point. 1.43. What is the ratio of the Balance of Payment (as % of service exports) in Uganda in 2005 to that in 2006?
Make the answer very short. 1.14. What is the ratio of the Balance of Payment (as % of service exports) in Comoros in 2005 to that in 2007?
Provide a short and direct response. 1.01. What is the ratio of the Balance of Payment (as % of service exports) of Cyprus in 2005 to that in 2007?
Keep it short and to the point. 1.19. What is the ratio of the Balance of Payment (as % of service exports) in Sierra Leone in 2005 to that in 2007?
Offer a terse response. 1.6. What is the ratio of the Balance of Payment (as % of service exports) in Uganda in 2005 to that in 2007?
Keep it short and to the point. 1.2. What is the ratio of the Balance of Payment (as % of service exports) in Comoros in 2005 to that in 2008?
Ensure brevity in your answer.  0.96. What is the ratio of the Balance of Payment (as % of service exports) in Cyprus in 2005 to that in 2008?
Keep it short and to the point. 1.28. What is the ratio of the Balance of Payment (as % of service exports) in Sierra Leone in 2005 to that in 2008?
Your answer should be compact. 1.43. What is the ratio of the Balance of Payment (as % of service exports) in Uganda in 2005 to that in 2008?
Provide a succinct answer. 1.21. What is the ratio of the Balance of Payment (as % of service exports) of Comoros in 2005 to that in 2009?
Make the answer very short. 1.02. What is the ratio of the Balance of Payment (as % of service exports) in Cyprus in 2005 to that in 2009?
Your answer should be very brief. 1.31. What is the ratio of the Balance of Payment (as % of service exports) in Sierra Leone in 2005 to that in 2009?
Provide a short and direct response. 3.25. What is the ratio of the Balance of Payment (as % of service exports) of Uganda in 2005 to that in 2009?
Keep it short and to the point. 1.11. What is the ratio of the Balance of Payment (as % of service exports) of Comoros in 2005 to that in 2010?
Ensure brevity in your answer.  1.02. What is the ratio of the Balance of Payment (as % of service exports) in Cyprus in 2005 to that in 2010?
Offer a terse response. 1.33. What is the ratio of the Balance of Payment (as % of service exports) of Sierra Leone in 2005 to that in 2010?
Keep it short and to the point. 1.8. What is the ratio of the Balance of Payment (as % of service exports) of Uganda in 2005 to that in 2010?
Your response must be concise. 1.2. What is the ratio of the Balance of Payment (as % of service exports) of Comoros in 2005 to that in 2011?
Ensure brevity in your answer.  0.98. What is the ratio of the Balance of Payment (as % of service exports) in Cyprus in 2005 to that in 2011?
Give a very brief answer. 1.18. What is the ratio of the Balance of Payment (as % of service exports) in Sierra Leone in 2005 to that in 2011?
Offer a terse response. 2.9. What is the ratio of the Balance of Payment (as % of service exports) of Uganda in 2005 to that in 2011?
Provide a succinct answer. 1.34. What is the ratio of the Balance of Payment (as % of service exports) of Cyprus in 2005 to that in 2012?
Provide a short and direct response. 1.08. What is the ratio of the Balance of Payment (as % of service exports) in Sierra Leone in 2005 to that in 2012?
Your answer should be very brief. 3.11. What is the ratio of the Balance of Payment (as % of service exports) in Uganda in 2005 to that in 2012?
Your answer should be compact. 1.33. What is the ratio of the Balance of Payment (as % of service exports) in Comoros in 2006 to that in 2007?
Your answer should be compact. 1.04. What is the ratio of the Balance of Payment (as % of service exports) of Cyprus in 2006 to that in 2007?
Your answer should be compact. 1.12. What is the ratio of the Balance of Payment (as % of service exports) in Sierra Leone in 2006 to that in 2007?
Provide a short and direct response. 1.12. What is the ratio of the Balance of Payment (as % of service exports) in Uganda in 2006 to that in 2007?
Keep it short and to the point. 1.05. What is the ratio of the Balance of Payment (as % of service exports) of Comoros in 2006 to that in 2008?
Your answer should be compact. 0.99. What is the ratio of the Balance of Payment (as % of service exports) in Cyprus in 2006 to that in 2008?
Your answer should be compact. 1.2. What is the ratio of the Balance of Payment (as % of service exports) of Uganda in 2006 to that in 2008?
Provide a short and direct response. 1.05. What is the ratio of the Balance of Payment (as % of service exports) of Comoros in 2006 to that in 2009?
Your answer should be compact. 1.06. What is the ratio of the Balance of Payment (as % of service exports) of Cyprus in 2006 to that in 2009?
Your answer should be very brief. 1.23. What is the ratio of the Balance of Payment (as % of service exports) of Sierra Leone in 2006 to that in 2009?
Keep it short and to the point. 2.28. What is the ratio of the Balance of Payment (as % of service exports) of Uganda in 2006 to that in 2009?
Provide a succinct answer. 0.97. What is the ratio of the Balance of Payment (as % of service exports) in Comoros in 2006 to that in 2010?
Offer a terse response. 1.06. What is the ratio of the Balance of Payment (as % of service exports) in Cyprus in 2006 to that in 2010?
Give a very brief answer. 1.24. What is the ratio of the Balance of Payment (as % of service exports) in Sierra Leone in 2006 to that in 2010?
Provide a succinct answer. 1.26. What is the ratio of the Balance of Payment (as % of service exports) of Uganda in 2006 to that in 2010?
Your response must be concise. 1.05. What is the ratio of the Balance of Payment (as % of service exports) of Comoros in 2006 to that in 2011?
Offer a very short reply. 1.02. What is the ratio of the Balance of Payment (as % of service exports) of Cyprus in 2006 to that in 2011?
Offer a very short reply. 1.11. What is the ratio of the Balance of Payment (as % of service exports) in Sierra Leone in 2006 to that in 2011?
Your answer should be compact. 2.03. What is the ratio of the Balance of Payment (as % of service exports) in Uganda in 2006 to that in 2011?
Keep it short and to the point. 1.17. What is the ratio of the Balance of Payment (as % of service exports) of Comoros in 2006 to that in 2012?
Offer a terse response. 1.04. What is the ratio of the Balance of Payment (as % of service exports) in Cyprus in 2006 to that in 2012?
Offer a very short reply. 1.01. What is the ratio of the Balance of Payment (as % of service exports) in Sierra Leone in 2006 to that in 2012?
Offer a very short reply. 2.18. What is the ratio of the Balance of Payment (as % of service exports) in Uganda in 2006 to that in 2012?
Offer a terse response. 1.17. What is the ratio of the Balance of Payment (as % of service exports) of Comoros in 2007 to that in 2008?
Ensure brevity in your answer.  0.95. What is the ratio of the Balance of Payment (as % of service exports) of Cyprus in 2007 to that in 2008?
Your answer should be very brief. 1.07. What is the ratio of the Balance of Payment (as % of service exports) in Sierra Leone in 2007 to that in 2008?
Provide a short and direct response. 0.89. What is the ratio of the Balance of Payment (as % of service exports) in Uganda in 2007 to that in 2008?
Your answer should be compact. 1. What is the ratio of the Balance of Payment (as % of service exports) in Comoros in 2007 to that in 2009?
Offer a terse response. 1.02. What is the ratio of the Balance of Payment (as % of service exports) in Cyprus in 2007 to that in 2009?
Ensure brevity in your answer.  1.1. What is the ratio of the Balance of Payment (as % of service exports) in Sierra Leone in 2007 to that in 2009?
Your answer should be very brief. 2.03. What is the ratio of the Balance of Payment (as % of service exports) in Uganda in 2007 to that in 2009?
Offer a terse response. 0.93. What is the ratio of the Balance of Payment (as % of service exports) in Comoros in 2007 to that in 2010?
Make the answer very short. 1.02. What is the ratio of the Balance of Payment (as % of service exports) of Cyprus in 2007 to that in 2010?
Keep it short and to the point. 1.11. What is the ratio of the Balance of Payment (as % of service exports) of Sierra Leone in 2007 to that in 2010?
Provide a short and direct response. 1.12. What is the ratio of the Balance of Payment (as % of service exports) of Uganda in 2007 to that in 2010?
Give a very brief answer. 1. What is the ratio of the Balance of Payment (as % of service exports) of Comoros in 2007 to that in 2011?
Offer a terse response. 0.97. What is the ratio of the Balance of Payment (as % of service exports) in Sierra Leone in 2007 to that in 2011?
Keep it short and to the point. 1.81. What is the ratio of the Balance of Payment (as % of service exports) in Uganda in 2007 to that in 2011?
Offer a terse response. 1.11. What is the ratio of the Balance of Payment (as % of service exports) of Comoros in 2007 to that in 2012?
Your answer should be very brief. 1. What is the ratio of the Balance of Payment (as % of service exports) in Cyprus in 2007 to that in 2012?
Ensure brevity in your answer.  0.9. What is the ratio of the Balance of Payment (as % of service exports) in Sierra Leone in 2007 to that in 2012?
Your response must be concise. 1.94. What is the ratio of the Balance of Payment (as % of service exports) in Uganda in 2007 to that in 2012?
Offer a very short reply. 1.11. What is the ratio of the Balance of Payment (as % of service exports) of Comoros in 2008 to that in 2009?
Your answer should be very brief. 1.07. What is the ratio of the Balance of Payment (as % of service exports) of Cyprus in 2008 to that in 2009?
Provide a succinct answer. 1.03. What is the ratio of the Balance of Payment (as % of service exports) in Sierra Leone in 2008 to that in 2009?
Your response must be concise. 2.27. What is the ratio of the Balance of Payment (as % of service exports) in Uganda in 2008 to that in 2009?
Keep it short and to the point. 0.92. What is the ratio of the Balance of Payment (as % of service exports) of Comoros in 2008 to that in 2010?
Offer a very short reply. 1.07. What is the ratio of the Balance of Payment (as % of service exports) of Cyprus in 2008 to that in 2010?
Make the answer very short. 1.04. What is the ratio of the Balance of Payment (as % of service exports) of Sierra Leone in 2008 to that in 2010?
Your response must be concise. 1.26. What is the ratio of the Balance of Payment (as % of service exports) in Uganda in 2008 to that in 2010?
Provide a short and direct response. 1. What is the ratio of the Balance of Payment (as % of service exports) of Comoros in 2008 to that in 2011?
Provide a short and direct response. 1.03. What is the ratio of the Balance of Payment (as % of service exports) in Cyprus in 2008 to that in 2011?
Your answer should be very brief. 0.93. What is the ratio of the Balance of Payment (as % of service exports) of Sierra Leone in 2008 to that in 2011?
Keep it short and to the point. 2.03. What is the ratio of the Balance of Payment (as % of service exports) in Uganda in 2008 to that in 2011?
Provide a short and direct response. 1.11. What is the ratio of the Balance of Payment (as % of service exports) in Comoros in 2008 to that in 2012?
Give a very brief answer. 1.05. What is the ratio of the Balance of Payment (as % of service exports) of Cyprus in 2008 to that in 2012?
Keep it short and to the point. 0.84. What is the ratio of the Balance of Payment (as % of service exports) in Sierra Leone in 2008 to that in 2012?
Keep it short and to the point. 2.18. What is the ratio of the Balance of Payment (as % of service exports) of Uganda in 2008 to that in 2012?
Your answer should be compact. 1.11. What is the ratio of the Balance of Payment (as % of service exports) in Comoros in 2009 to that in 2010?
Ensure brevity in your answer.  1. What is the ratio of the Balance of Payment (as % of service exports) of Cyprus in 2009 to that in 2010?
Your answer should be compact. 1.01. What is the ratio of the Balance of Payment (as % of service exports) of Sierra Leone in 2009 to that in 2010?
Give a very brief answer. 0.55. What is the ratio of the Balance of Payment (as % of service exports) in Uganda in 2009 to that in 2010?
Ensure brevity in your answer.  1.08. What is the ratio of the Balance of Payment (as % of service exports) in Comoros in 2009 to that in 2011?
Offer a very short reply. 0.96. What is the ratio of the Balance of Payment (as % of service exports) in Cyprus in 2009 to that in 2011?
Offer a terse response. 0.9. What is the ratio of the Balance of Payment (as % of service exports) of Sierra Leone in 2009 to that in 2011?
Provide a short and direct response. 0.89. What is the ratio of the Balance of Payment (as % of service exports) in Uganda in 2009 to that in 2011?
Ensure brevity in your answer.  1.2. What is the ratio of the Balance of Payment (as % of service exports) of Comoros in 2009 to that in 2012?
Keep it short and to the point. 0.98. What is the ratio of the Balance of Payment (as % of service exports) in Cyprus in 2009 to that in 2012?
Your answer should be compact. 0.82. What is the ratio of the Balance of Payment (as % of service exports) in Sierra Leone in 2009 to that in 2012?
Your response must be concise. 0.96. What is the ratio of the Balance of Payment (as % of service exports) in Uganda in 2009 to that in 2012?
Offer a terse response. 1.2. What is the ratio of the Balance of Payment (as % of service exports) of Comoros in 2010 to that in 2011?
Your answer should be very brief. 0.96. What is the ratio of the Balance of Payment (as % of service exports) in Cyprus in 2010 to that in 2011?
Ensure brevity in your answer.  0.89. What is the ratio of the Balance of Payment (as % of service exports) in Sierra Leone in 2010 to that in 2011?
Provide a succinct answer. 1.61. What is the ratio of the Balance of Payment (as % of service exports) of Uganda in 2010 to that in 2011?
Ensure brevity in your answer.  1.11. What is the ratio of the Balance of Payment (as % of service exports) in Comoros in 2010 to that in 2012?
Your response must be concise. 0.98. What is the ratio of the Balance of Payment (as % of service exports) of Cyprus in 2010 to that in 2012?
Provide a short and direct response. 0.81. What is the ratio of the Balance of Payment (as % of service exports) in Sierra Leone in 2010 to that in 2012?
Your answer should be compact. 1.73. What is the ratio of the Balance of Payment (as % of service exports) in Uganda in 2010 to that in 2012?
Your answer should be very brief. 1.11. What is the ratio of the Balance of Payment (as % of service exports) in Comoros in 2011 to that in 2012?
Give a very brief answer. 1.02. What is the ratio of the Balance of Payment (as % of service exports) of Cyprus in 2011 to that in 2012?
Provide a short and direct response. 0.91. What is the ratio of the Balance of Payment (as % of service exports) of Sierra Leone in 2011 to that in 2012?
Provide a succinct answer. 1.07. What is the ratio of the Balance of Payment (as % of service exports) of Uganda in 2011 to that in 2012?
Ensure brevity in your answer.  1. What is the difference between the highest and the second highest Balance of Payment (as % of service exports) of Comoros?
Offer a terse response. 0.54. What is the difference between the highest and the second highest Balance of Payment (as % of service exports) of Cyprus?
Your answer should be very brief. 2.4. What is the difference between the highest and the second highest Balance of Payment (as % of service exports) of Sierra Leone?
Provide a succinct answer. 24.47. What is the difference between the highest and the second highest Balance of Payment (as % of service exports) of Uganda?
Offer a very short reply. 7.25. What is the difference between the highest and the lowest Balance of Payment (as % of service exports) in Comoros?
Your answer should be very brief. 3.85. What is the difference between the highest and the lowest Balance of Payment (as % of service exports) of Cyprus?
Give a very brief answer. 9.49. What is the difference between the highest and the lowest Balance of Payment (as % of service exports) of Sierra Leone?
Keep it short and to the point. 56.75. What is the difference between the highest and the lowest Balance of Payment (as % of service exports) of Uganda?
Ensure brevity in your answer.  18.23. 